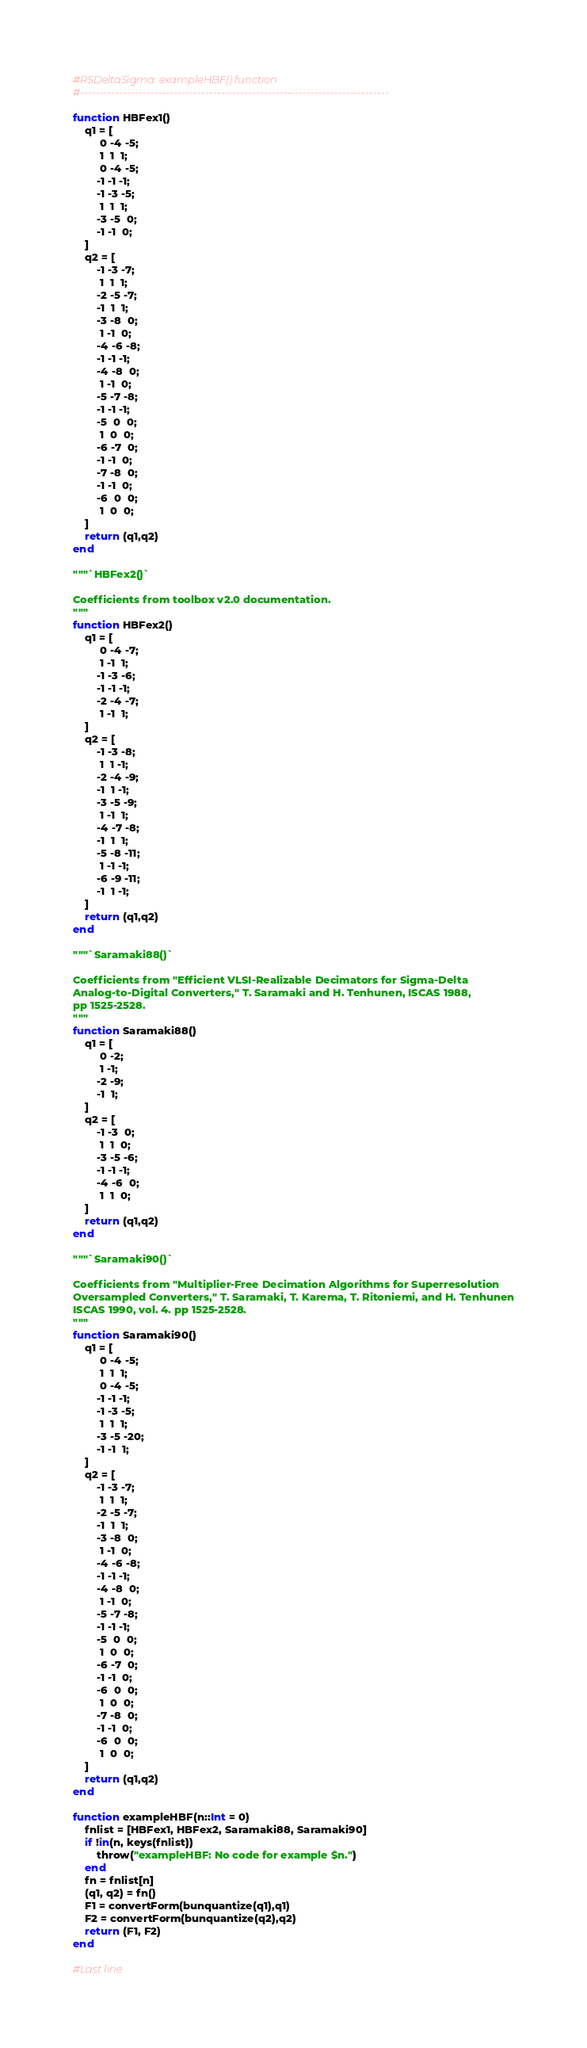Convert code to text. <code><loc_0><loc_0><loc_500><loc_500><_Julia_>#RSDeltaSigma: exampleHBF() function
#-------------------------------------------------------------------------------

function HBFex1()
	q1 = [
		 0 -4 -5;
		 1  1  1;
		 0 -4 -5;
		-1 -1 -1;
		-1 -3 -5;
		 1  1  1;
		-3 -5  0;
		-1 -1  0;
	]
	q2 = [
		-1 -3 -7;
		 1  1  1;
		-2 -5 -7;
		-1  1  1;
		-3 -8  0;
		 1 -1  0;
		-4 -6 -8;
		-1 -1 -1;
		-4 -8  0;
		 1 -1  0;
		-5 -7 -8;
		-1 -1 -1;
		-5  0  0;
		 1  0  0;
		-6 -7  0;
		-1 -1  0;
		-7 -8  0;
		-1 -1  0;
		-6  0  0;
		 1  0  0;
	]
	return (q1,q2)
end

"""`HBFex2()`

Coefficients from toolbox v2.0 documentation.
"""
function HBFex2()
	q1 = [
		 0 -4 -7;
		 1 -1  1;
		-1 -3 -6;
		-1 -1 -1;
		-2 -4 -7;
		 1 -1  1;
	]
	q2 = [
		-1 -3 -8;
		 1  1 -1;
		-2 -4 -9;
		-1  1 -1;
		-3 -5 -9;
		 1 -1  1;
		-4 -7 -8;
		-1  1  1;
		-5 -8 -11;
		 1 -1 -1;
		-6 -9 -11;
		-1  1 -1;
	]
	return (q1,q2)
end

"""`Saramaki88()`

Coefficients from "Efficient VLSI-Realizable Decimators for Sigma-Delta
Analog-to-Digital Converters," T. Saramaki and H. Tenhunen, ISCAS 1988,
pp 1525-2528.
"""
function Saramaki88()
	q1 = [
		 0 -2;
		 1 -1;
		-2 -9;
		-1  1;
	]
	q2 = [
		-1 -3  0;
		 1  1  0;
		-3 -5 -6;
		-1 -1 -1;
		-4 -6  0;
		 1  1  0;
	]
	return (q1,q2)
end

"""`Saramaki90()`

Coefficients from "Multiplier-Free Decimation Algorithms for Superresolution
Oversampled Converters," T. Saramaki, T. Karema, T. Ritoniemi, and H. Tenhunen
ISCAS 1990, vol. 4. pp 1525-2528.
"""
function Saramaki90()
	q1 = [
		 0 -4 -5;
		 1  1  1;
		 0 -4 -5;
		-1 -1 -1;
		-1 -3 -5;
		 1  1  1;
		-3 -5 -20;
		-1 -1  1;
	]
	q2 = [
		-1 -3 -7;
		 1  1  1;
		-2 -5 -7;
		-1  1  1;
		-3 -8  0;
		 1 -1  0;
		-4 -6 -8;
		-1 -1 -1;
		-4 -8  0;
		 1 -1  0;
		-5 -7 -8;
		-1 -1 -1;
		-5  0  0;
		 1  0  0;
		-6 -7  0;
		-1 -1  0;
		-6  0  0;
		 1  0  0;
		-7 -8  0;
		-1 -1  0;
		-6  0  0;
		 1  0  0;
	]
	return (q1,q2)
end

function exampleHBF(n::Int = 0)
	fnlist = [HBFex1, HBFex2, Saramaki88, Saramaki90]
	if !in(n, keys(fnlist))
		throw("exampleHBF: No code for example $n.")
	end
	fn = fnlist[n]
	(q1, q2) = fn()
	F1 = convertForm(bunquantize(q1),q1)
	F2 = convertForm(bunquantize(q2),q2)
	return (F1, F2)
end

#Last line
</code> 